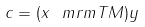Convert formula to latex. <formula><loc_0><loc_0><loc_500><loc_500>c = ( x ^ { \ } m r m { T } M ) y</formula> 